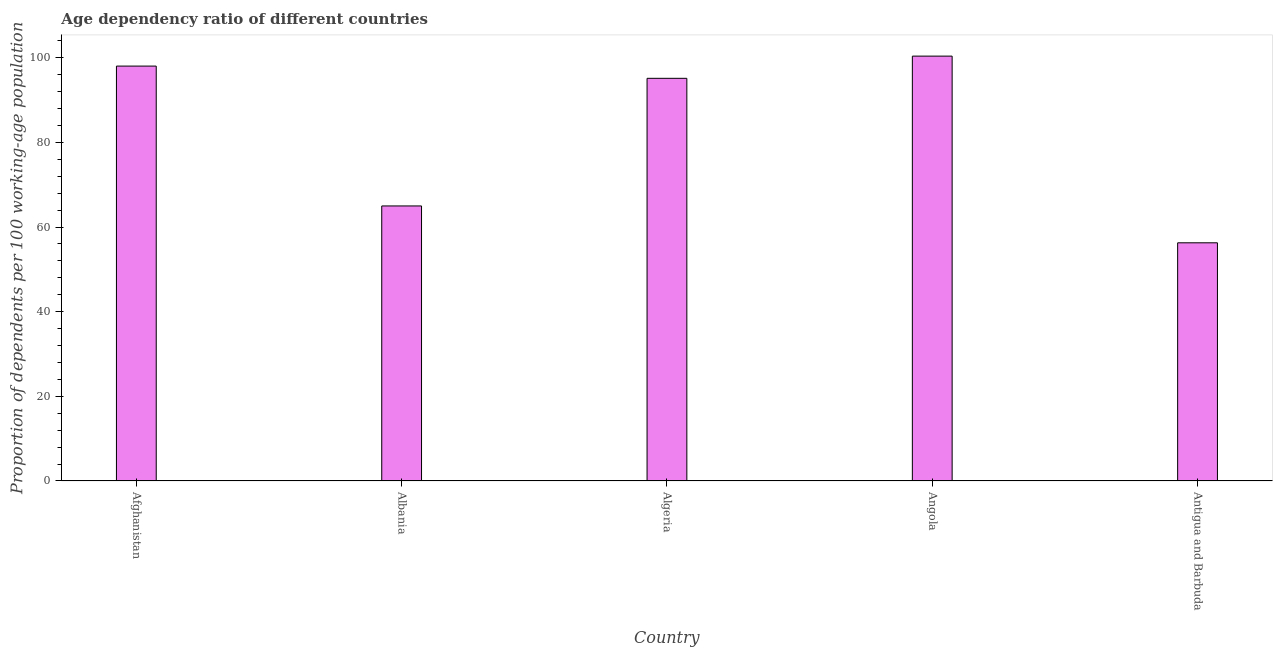Does the graph contain any zero values?
Provide a short and direct response. No. Does the graph contain grids?
Provide a succinct answer. No. What is the title of the graph?
Provide a short and direct response. Age dependency ratio of different countries. What is the label or title of the X-axis?
Your answer should be very brief. Country. What is the label or title of the Y-axis?
Provide a succinct answer. Proportion of dependents per 100 working-age population. What is the age dependency ratio in Angola?
Provide a short and direct response. 100.38. Across all countries, what is the maximum age dependency ratio?
Provide a succinct answer. 100.38. Across all countries, what is the minimum age dependency ratio?
Offer a terse response. 56.27. In which country was the age dependency ratio maximum?
Your response must be concise. Angola. In which country was the age dependency ratio minimum?
Provide a succinct answer. Antigua and Barbuda. What is the sum of the age dependency ratio?
Keep it short and to the point. 414.79. What is the difference between the age dependency ratio in Afghanistan and Antigua and Barbuda?
Offer a very short reply. 41.75. What is the average age dependency ratio per country?
Offer a very short reply. 82.96. What is the median age dependency ratio?
Provide a succinct answer. 95.13. What is the ratio of the age dependency ratio in Albania to that in Antigua and Barbuda?
Give a very brief answer. 1.16. Is the difference between the age dependency ratio in Angola and Antigua and Barbuda greater than the difference between any two countries?
Ensure brevity in your answer.  Yes. What is the difference between the highest and the second highest age dependency ratio?
Offer a very short reply. 2.35. What is the difference between the highest and the lowest age dependency ratio?
Offer a very short reply. 44.1. In how many countries, is the age dependency ratio greater than the average age dependency ratio taken over all countries?
Provide a short and direct response. 3. How many bars are there?
Make the answer very short. 5. How many countries are there in the graph?
Your answer should be compact. 5. What is the difference between two consecutive major ticks on the Y-axis?
Provide a succinct answer. 20. Are the values on the major ticks of Y-axis written in scientific E-notation?
Your answer should be very brief. No. What is the Proportion of dependents per 100 working-age population of Afghanistan?
Provide a short and direct response. 98.02. What is the Proportion of dependents per 100 working-age population in Albania?
Provide a succinct answer. 64.98. What is the Proportion of dependents per 100 working-age population of Algeria?
Give a very brief answer. 95.13. What is the Proportion of dependents per 100 working-age population of Angola?
Give a very brief answer. 100.38. What is the Proportion of dependents per 100 working-age population of Antigua and Barbuda?
Ensure brevity in your answer.  56.27. What is the difference between the Proportion of dependents per 100 working-age population in Afghanistan and Albania?
Offer a very short reply. 33.04. What is the difference between the Proportion of dependents per 100 working-age population in Afghanistan and Algeria?
Make the answer very short. 2.89. What is the difference between the Proportion of dependents per 100 working-age population in Afghanistan and Angola?
Provide a succinct answer. -2.35. What is the difference between the Proportion of dependents per 100 working-age population in Afghanistan and Antigua and Barbuda?
Your response must be concise. 41.75. What is the difference between the Proportion of dependents per 100 working-age population in Albania and Algeria?
Your response must be concise. -30.15. What is the difference between the Proportion of dependents per 100 working-age population in Albania and Angola?
Your answer should be very brief. -35.39. What is the difference between the Proportion of dependents per 100 working-age population in Albania and Antigua and Barbuda?
Your answer should be very brief. 8.71. What is the difference between the Proportion of dependents per 100 working-age population in Algeria and Angola?
Your answer should be compact. -5.24. What is the difference between the Proportion of dependents per 100 working-age population in Algeria and Antigua and Barbuda?
Offer a terse response. 38.86. What is the difference between the Proportion of dependents per 100 working-age population in Angola and Antigua and Barbuda?
Provide a succinct answer. 44.1. What is the ratio of the Proportion of dependents per 100 working-age population in Afghanistan to that in Albania?
Offer a very short reply. 1.51. What is the ratio of the Proportion of dependents per 100 working-age population in Afghanistan to that in Algeria?
Give a very brief answer. 1.03. What is the ratio of the Proportion of dependents per 100 working-age population in Afghanistan to that in Antigua and Barbuda?
Ensure brevity in your answer.  1.74. What is the ratio of the Proportion of dependents per 100 working-age population in Albania to that in Algeria?
Ensure brevity in your answer.  0.68. What is the ratio of the Proportion of dependents per 100 working-age population in Albania to that in Angola?
Ensure brevity in your answer.  0.65. What is the ratio of the Proportion of dependents per 100 working-age population in Albania to that in Antigua and Barbuda?
Ensure brevity in your answer.  1.16. What is the ratio of the Proportion of dependents per 100 working-age population in Algeria to that in Angola?
Provide a short and direct response. 0.95. What is the ratio of the Proportion of dependents per 100 working-age population in Algeria to that in Antigua and Barbuda?
Your answer should be very brief. 1.69. What is the ratio of the Proportion of dependents per 100 working-age population in Angola to that in Antigua and Barbuda?
Your response must be concise. 1.78. 